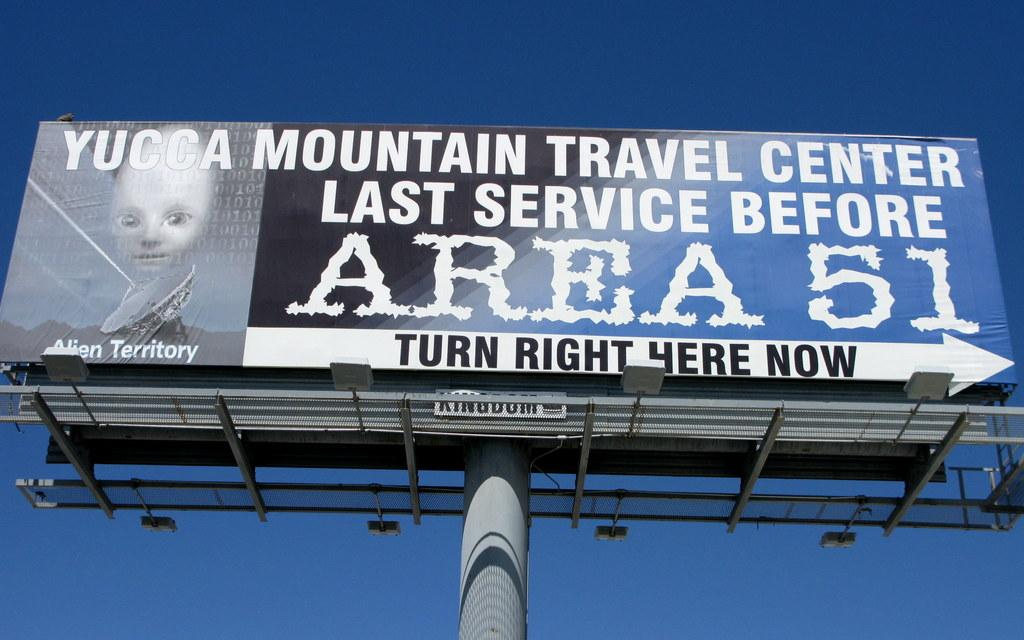Provide a one-sentence caption for the provided image. A billboard with the message "Yucca Mountain Travel Center Last Service Before Area 51". 